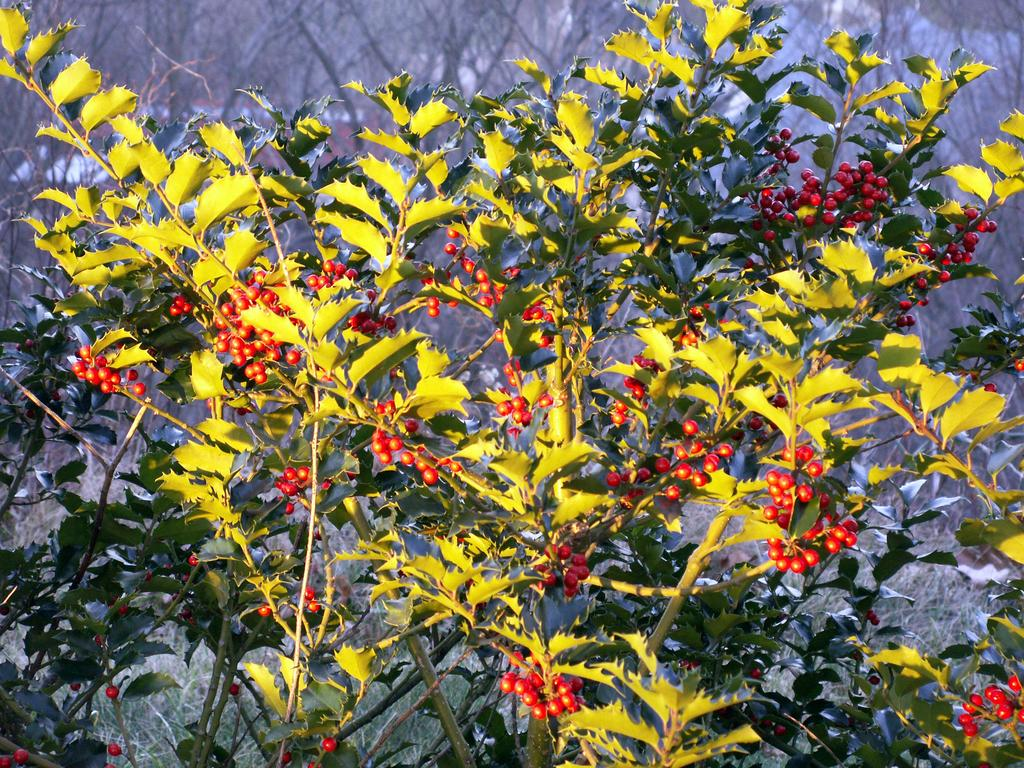What types of living organisms can be seen in the image? Plants and fruits are visible in the image. Can you describe the fruits in the image? The image contains fruits, but the specific types cannot be determined from the provided facts. What is the condition of the background in the image? The background of the image is blurry. What type of silver object is visible in the image? There is no silver object present in the image. Are there any cacti in the image? The provided facts do not mention cacti, so it cannot be determined if they are present in the image. Can you describe the shape of the circle in the image? There is no circle present in the image. 